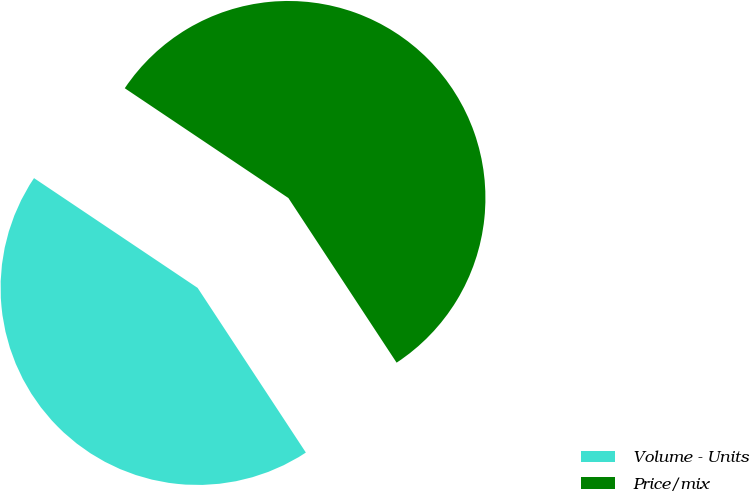<chart> <loc_0><loc_0><loc_500><loc_500><pie_chart><fcel>Volume - Units<fcel>Price/mix<nl><fcel>43.66%<fcel>56.34%<nl></chart> 